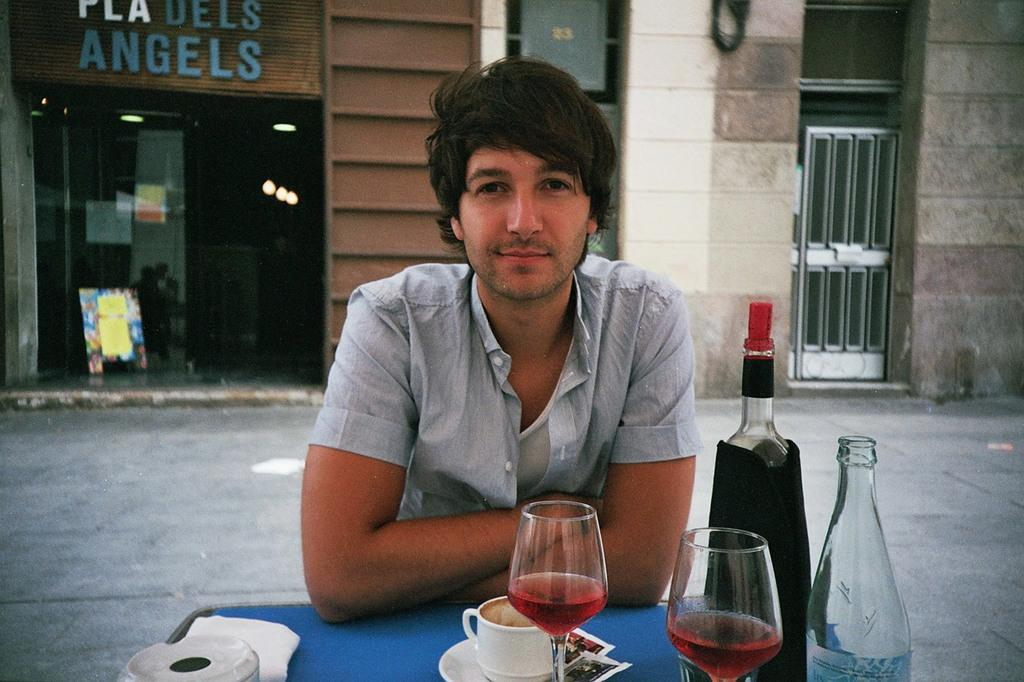What is the person in the image doing? The person is sitting on a chair in the image. Where is the person sitting in relation to the table? The person is beside the table. What items can be seen on the table? There is a wine glass, a cup and saucer, and a bottle on the table. What can be seen in the background of the image? There is a shop and a door visible in the background. What type of process is being demonstrated by the person in the image? There is no process being demonstrated by the person in the image; they are simply sitting on a chair. What type of scarf is the person wearing in the image? There is no scarf visible in the image. 